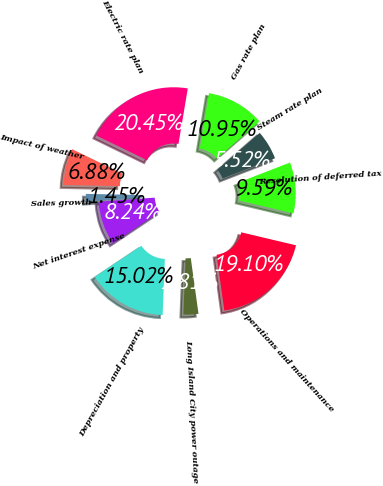<chart> <loc_0><loc_0><loc_500><loc_500><pie_chart><fcel>Sales growth<fcel>Impact of weather<fcel>Electric rate plan<fcel>Gas rate plan<fcel>Steam rate plan<fcel>Resolution of deferred tax<fcel>Operations and maintenance<fcel>Long Island City power outage<fcel>Depreciation and property<fcel>Net interest expense<nl><fcel>1.45%<fcel>6.88%<fcel>20.45%<fcel>10.95%<fcel>5.52%<fcel>9.59%<fcel>19.1%<fcel>2.81%<fcel>15.02%<fcel>8.24%<nl></chart> 